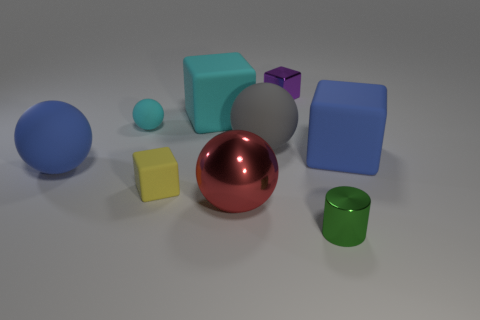Subtract 1 cubes. How many cubes are left? 3 Subtract all spheres. How many objects are left? 5 Add 8 large red metallic objects. How many large red metallic objects are left? 9 Add 1 purple metal objects. How many purple metal objects exist? 2 Subtract 0 purple cylinders. How many objects are left? 9 Subtract all large gray metallic spheres. Subtract all big balls. How many objects are left? 6 